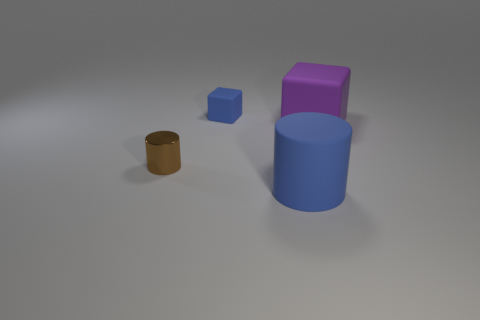What time of day does the lighting in the scene suggest? The shadows cast by the objects and the overall tone of the lighting suggest a diffuse light source, not directly indicative of a particular time of day. It's similar to an overcast sky or indoor lighting from a single source, giving the scene a calm and even illumination. 